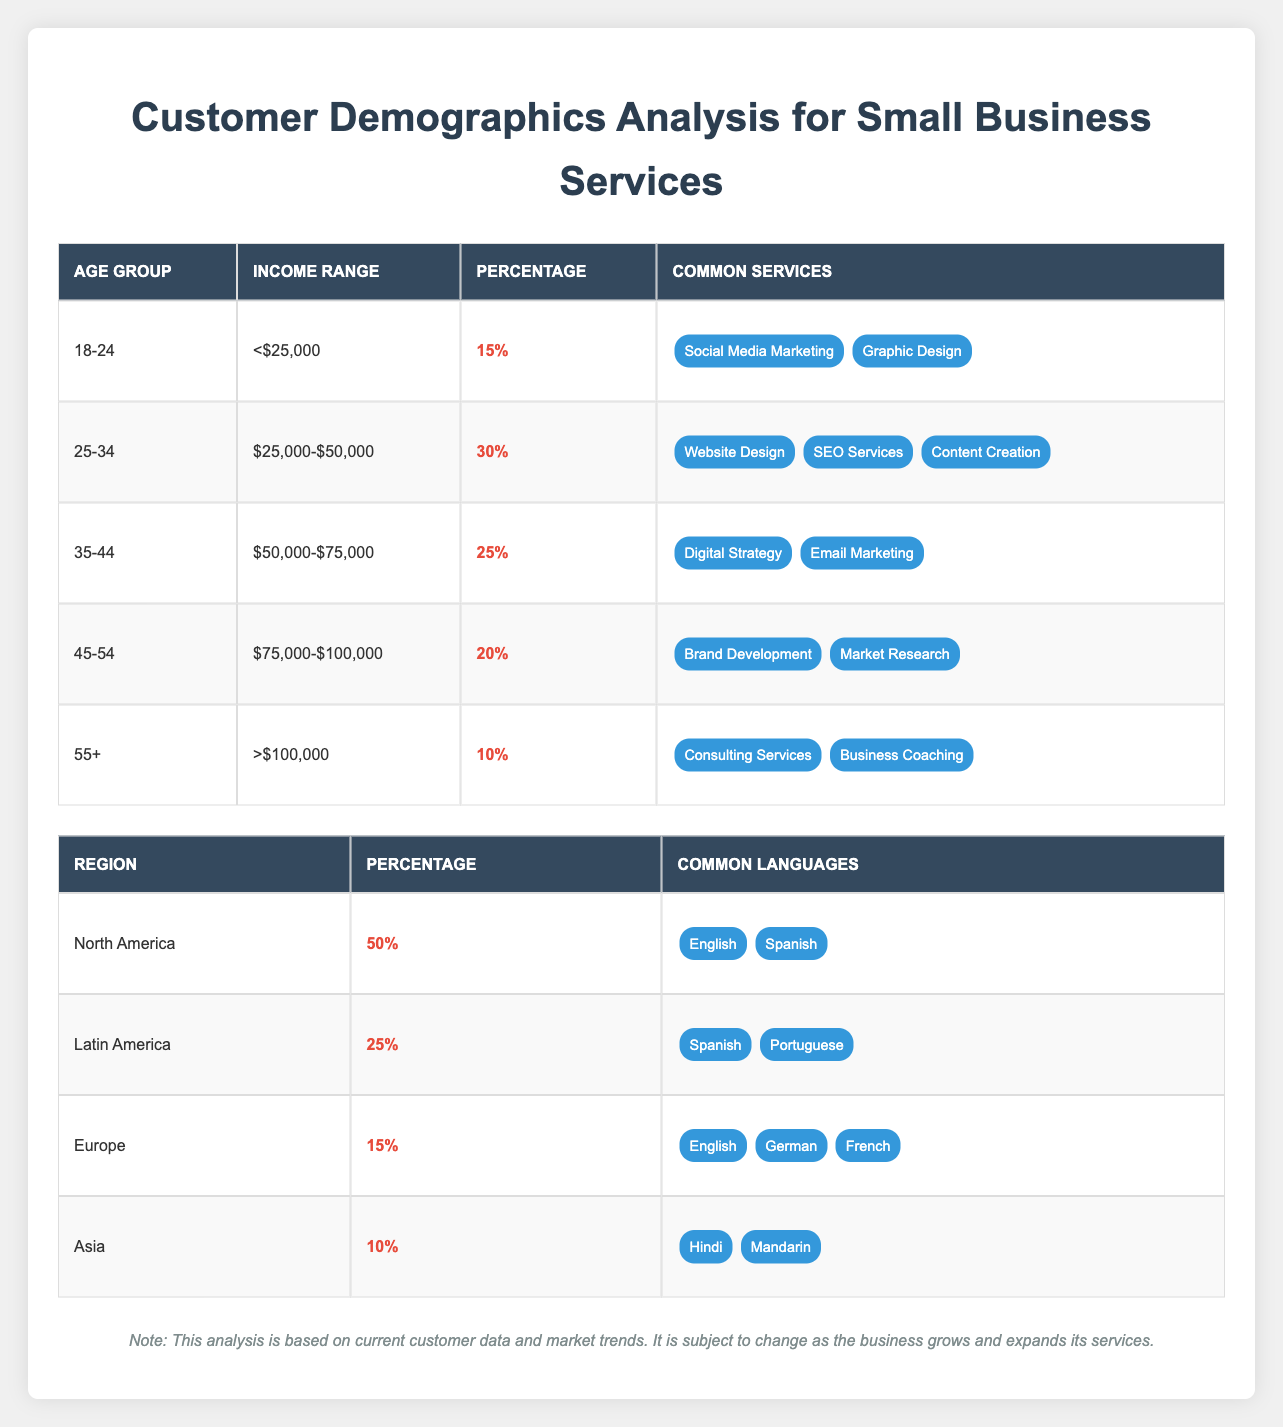What percentage of customers are aged 25-34? By referring to the table under the "Age Group" column, we can see that the specified age group "25-34" has a percentage of 30% listed next to it.
Answer: 30% What are the common services for customers aged 45-54? Looking at the "Common Services" column for the age group "45-54", the listed services are "Brand Development" and "Market Research".
Answer: Brand Development, Market Research Which age group has the highest percentage of customers? Scanning through the "Percentage" column, the highest value is 30%, which corresponds to the "25-34" age group, as no other age group exceeds this percentage.
Answer: 25-34 Is it true that customers from Asia make up 15% of the total? Checking the "Percentage" for the region "Asia", it shows 10%. Therefore, the statement is false, as it does not match the given percentage.
Answer: No What is the combined percentage of customers aged 35-44 and 45-54? The percentage for "35-44" is 25% and for "45-54" it is 20%. Adding these two percentages gives us a total of 25% + 20% = 45%.
Answer: 45% How many common languages are spoken by customers from Latin America? In the "Common Languages" section for "Latin America", the languages listed are "Spanish" and "Portuguese", which totals to two languages.
Answer: 2 What is the most common income range for customers aged 18-24? The income range given for the "18-24" age group is "<$25,000", hence this is the most common income range for this group.
Answer: <$25,000 Which region has the highest percentage of customers and what is that percentage? By reflecting on the "Percentage" column for regions, "North America" has the highest percentage at 50%.
Answer: North America, 50% 